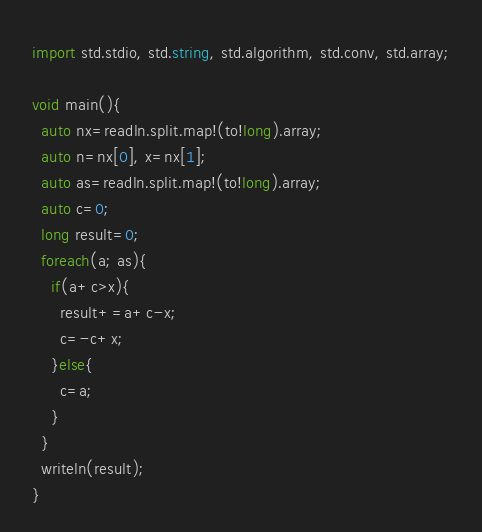<code> <loc_0><loc_0><loc_500><loc_500><_D_>import std.stdio, std.string, std.algorithm, std.conv, std.array;

void main(){
  auto nx=readln.split.map!(to!long).array;
  auto n=nx[0], x=nx[1];
  auto as=readln.split.map!(to!long).array;
  auto c=0;
  long result=0;
  foreach(a; as){
    if(a+c>x){
      result+=a+c-x;
      c=-c+x;
    }else{
      c=a;
    }
  }
  writeln(result);
}
</code> 